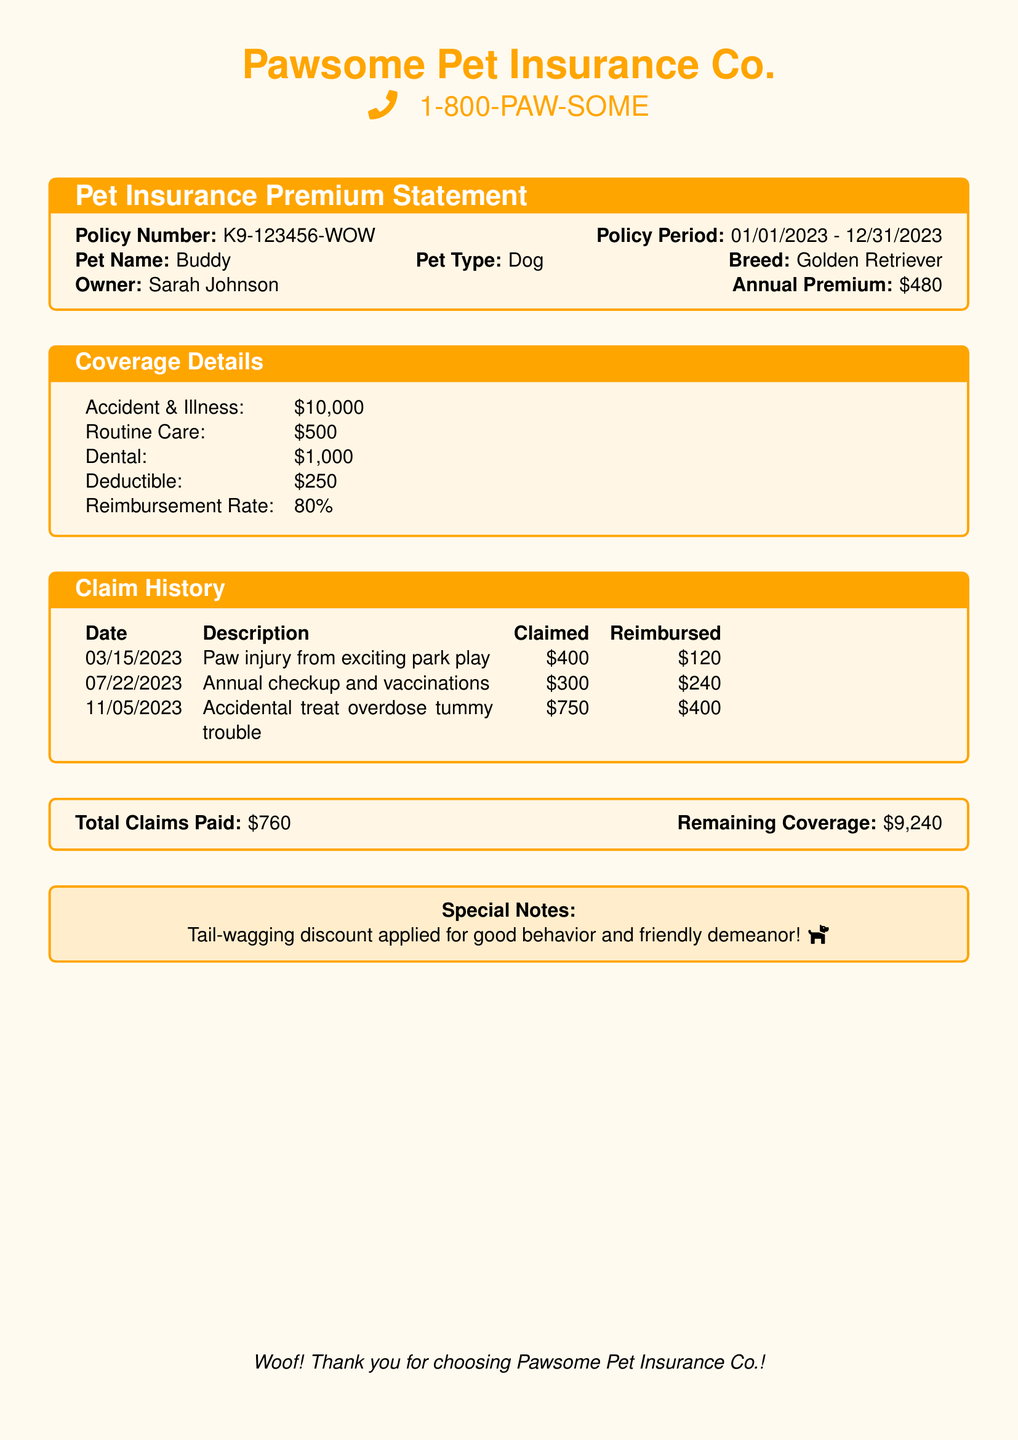what is the policy number? The policy number is clearly stated in the document under the Pet Insurance Premium Statement section.
Answer: K9-123456-WOW what is Buddy's breed? The breed of Buddy is mentioned in the policy details of the document.
Answer: Golden Retriever what is the annual premium for the policy? The annual premium is provided in the Premium Statement section of the document.
Answer: $480 how much was claimed for the paw injury? The claimed amount for the paw injury is specified in the Claim History section of the document.
Answer: $400 what was reimbursed for the accidental treat overdose? The reimbursed amount for the accidental treat overdose is listed in the claim history.
Answer: $400 what is the remaining coverage after claims? The remaining coverage is stated at the bottom of the document, summarizing all claims paid.
Answer: $9,240 what is the maximum coverage for routine care? The maximum coverage for routine care is found in the Coverage Details section of the document.
Answer: $500 how many claims were paid in total? The total claims paid is summarized at the end of the Claim History section.
Answer: $760 what special discount is mentioned in the document? The special discount provided is noted towards the end of the document.
Answer: Tail-wagging discount 